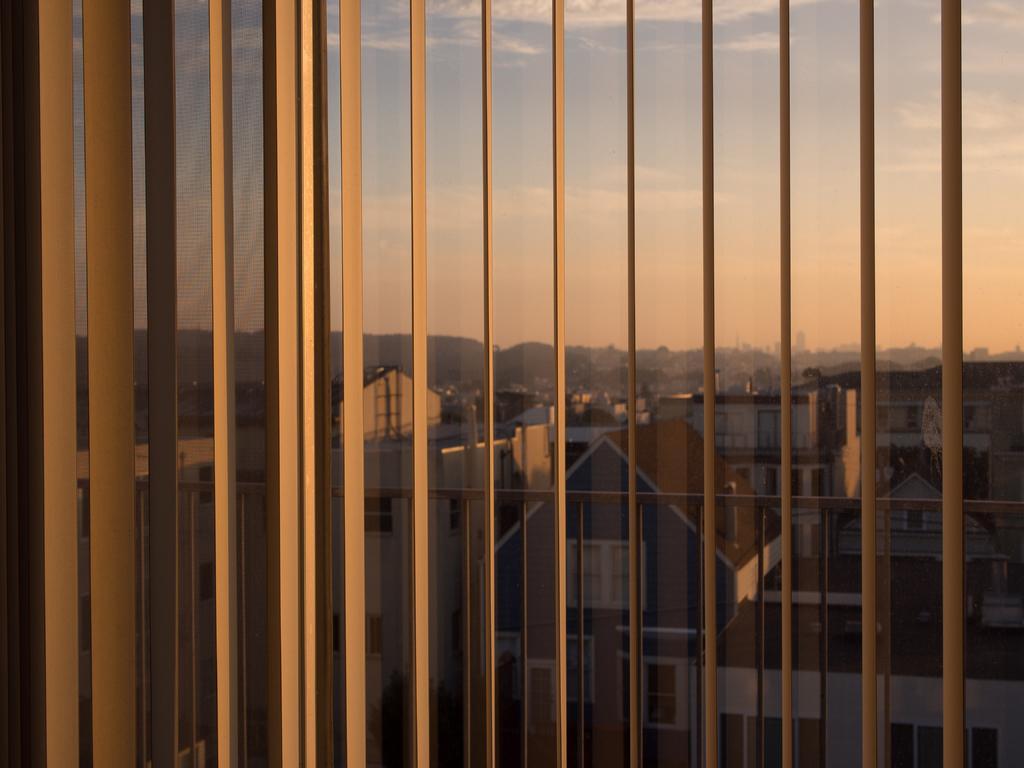How would you summarize this image in a sentence or two? In the image we can see window blinds and the window. Out of the window we can see there are many buildings and the cloudy sky. 